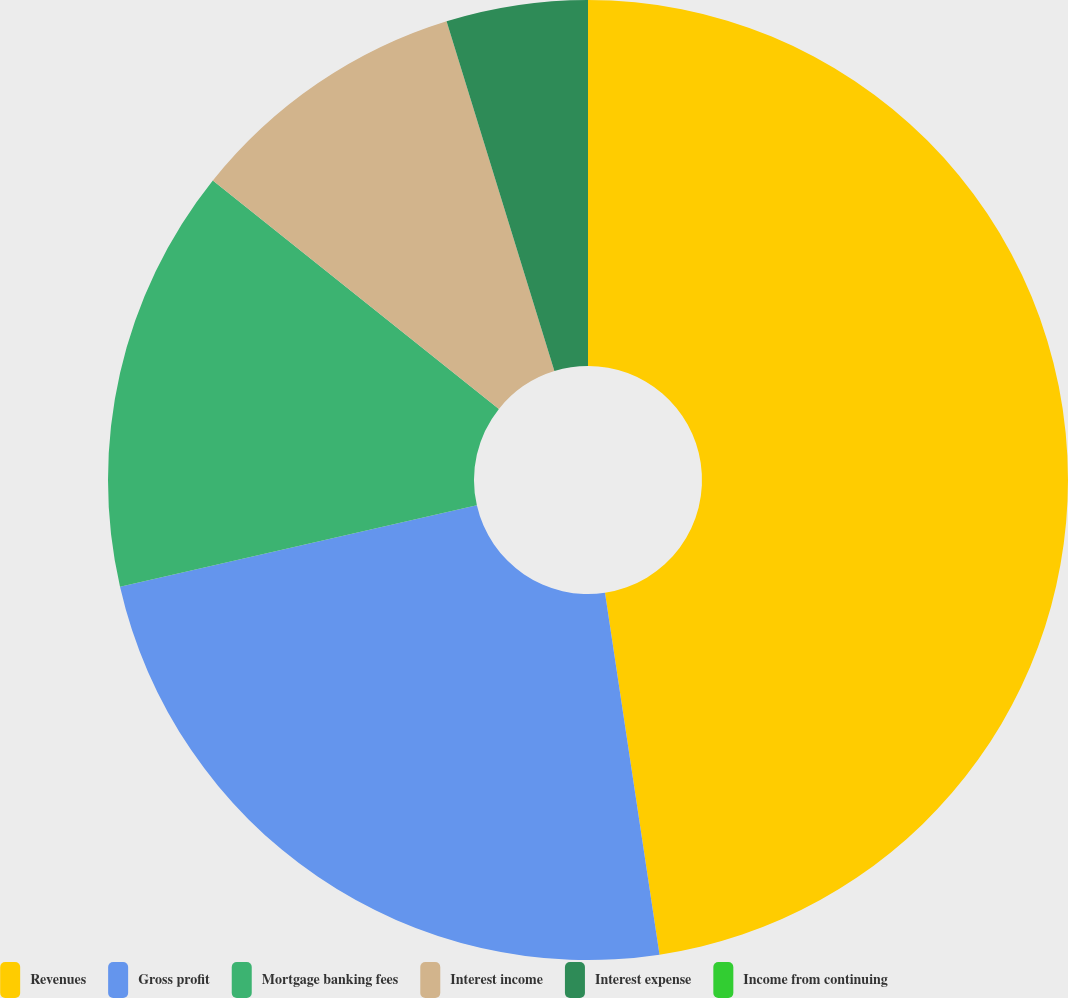<chart> <loc_0><loc_0><loc_500><loc_500><pie_chart><fcel>Revenues<fcel>Gross profit<fcel>Mortgage banking fees<fcel>Interest income<fcel>Interest expense<fcel>Income from continuing<nl><fcel>47.62%<fcel>23.81%<fcel>14.29%<fcel>9.52%<fcel>4.76%<fcel>0.0%<nl></chart> 